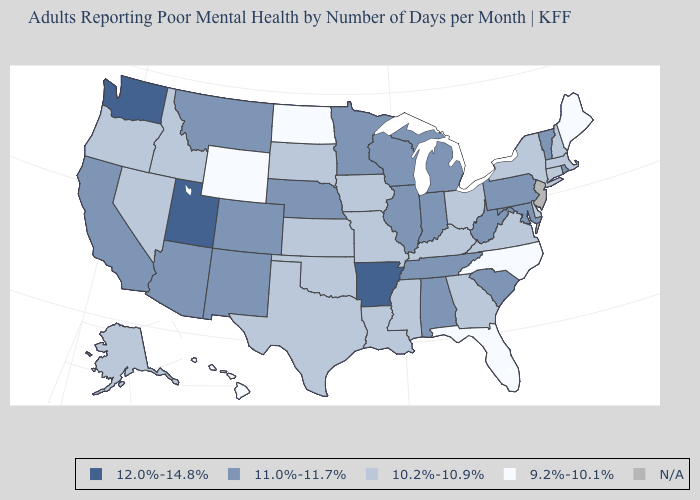Which states hav the highest value in the Northeast?
Be succinct. Pennsylvania, Rhode Island, Vermont. Does the first symbol in the legend represent the smallest category?
Give a very brief answer. No. Which states hav the highest value in the MidWest?
Short answer required. Illinois, Indiana, Michigan, Minnesota, Nebraska, Wisconsin. Among the states that border Massachusetts , which have the lowest value?
Write a very short answer. Connecticut, New Hampshire, New York. What is the lowest value in states that border Georgia?
Keep it brief. 9.2%-10.1%. What is the highest value in the MidWest ?
Short answer required. 11.0%-11.7%. Does Wyoming have the lowest value in the USA?
Quick response, please. Yes. Which states hav the highest value in the West?
Keep it brief. Utah, Washington. How many symbols are there in the legend?
Short answer required. 5. What is the lowest value in the USA?
Be succinct. 9.2%-10.1%. How many symbols are there in the legend?
Be succinct. 5. Which states have the highest value in the USA?
Answer briefly. Arkansas, Utah, Washington. What is the lowest value in states that border Indiana?
Give a very brief answer. 10.2%-10.9%. 